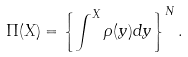Convert formula to latex. <formula><loc_0><loc_0><loc_500><loc_500>\Pi ( X ) = \left \{ \int ^ { X } \rho ( y ) d y \right \} ^ { N } .</formula> 